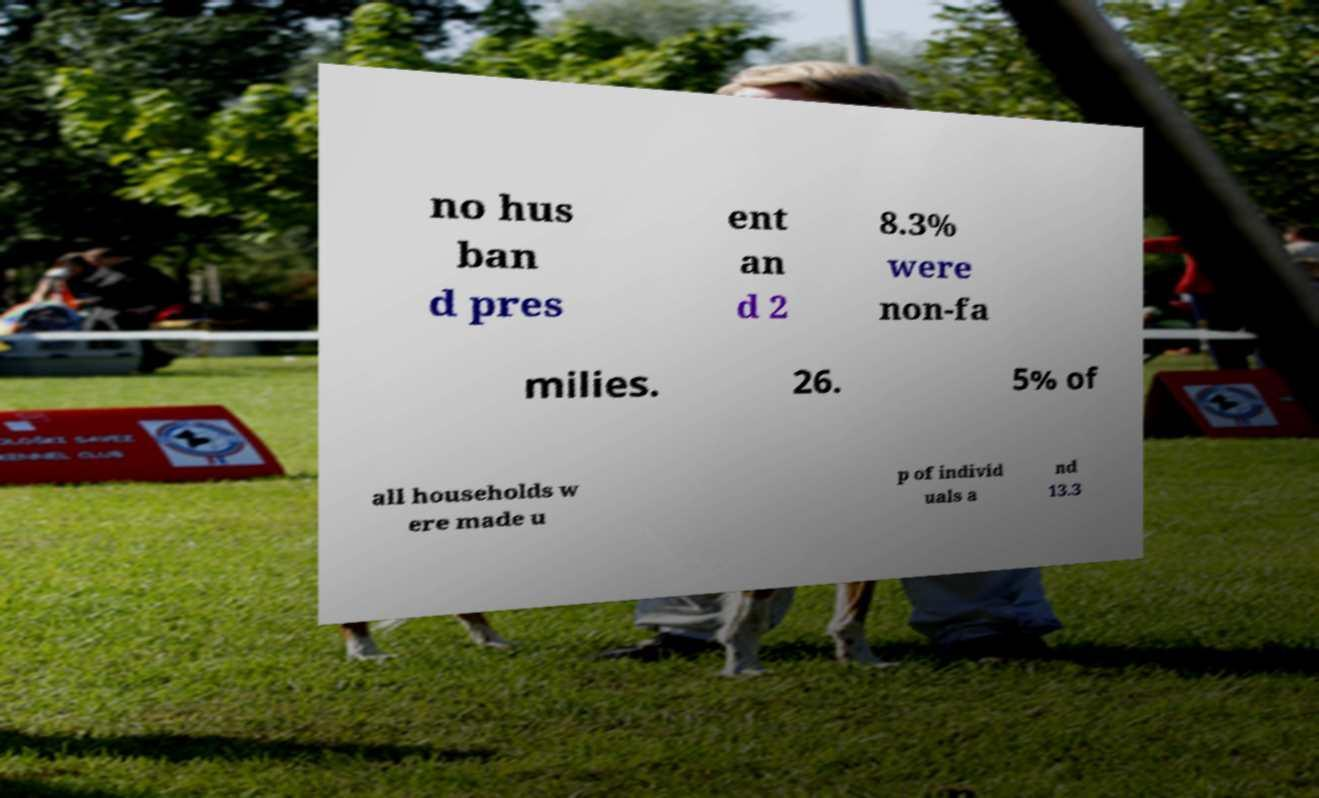There's text embedded in this image that I need extracted. Can you transcribe it verbatim? no hus ban d pres ent an d 2 8.3% were non-fa milies. 26. 5% of all households w ere made u p of individ uals a nd 13.3 